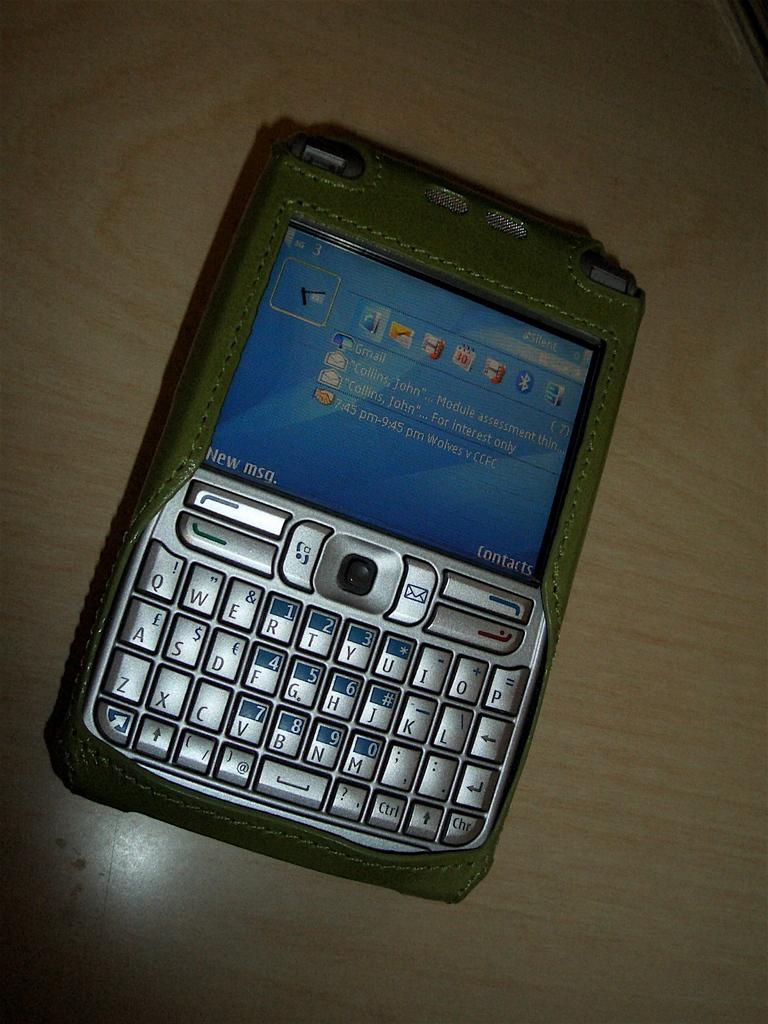What electronic device can be seen in the image? There is a mobile phone in the image. Where is the mobile phone located? The mobile phone is placed on a surface. What can be seen on the mobile phone's screen? There is text visible on the mobile phone's screen. What type of pipe can be seen connecting the mobile phone to the wall in the image? There is no pipe connecting the mobile phone to the wall in the image; the mobile phone is placed on a surface without any visible connections. 